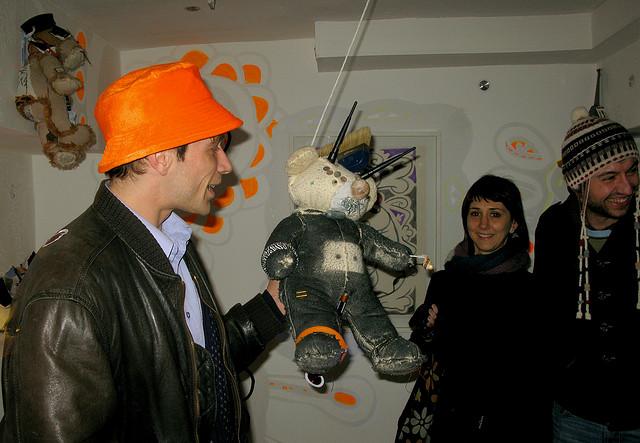What is on the floor in the back?
Concise answer only. Rug. What sort of celebration is this?
Write a very short answer. Birthday. What color hat is the man in the foreground wearing?
Be succinct. Orange. Does that look like it used to be a teddy bear?
Concise answer only. Yes. What is the object hanging from the roof?
Concise answer only. Yes. Why is he dressed like that?
Quick response, please. Party. What holiday is being celebrated?
Give a very brief answer. Halloween. Where are they going?
Write a very short answer. Outside. What is odd about the cat dolls face?
Give a very brief answer. Horns. What does this playset portray?
Give a very brief answer. Bear. 